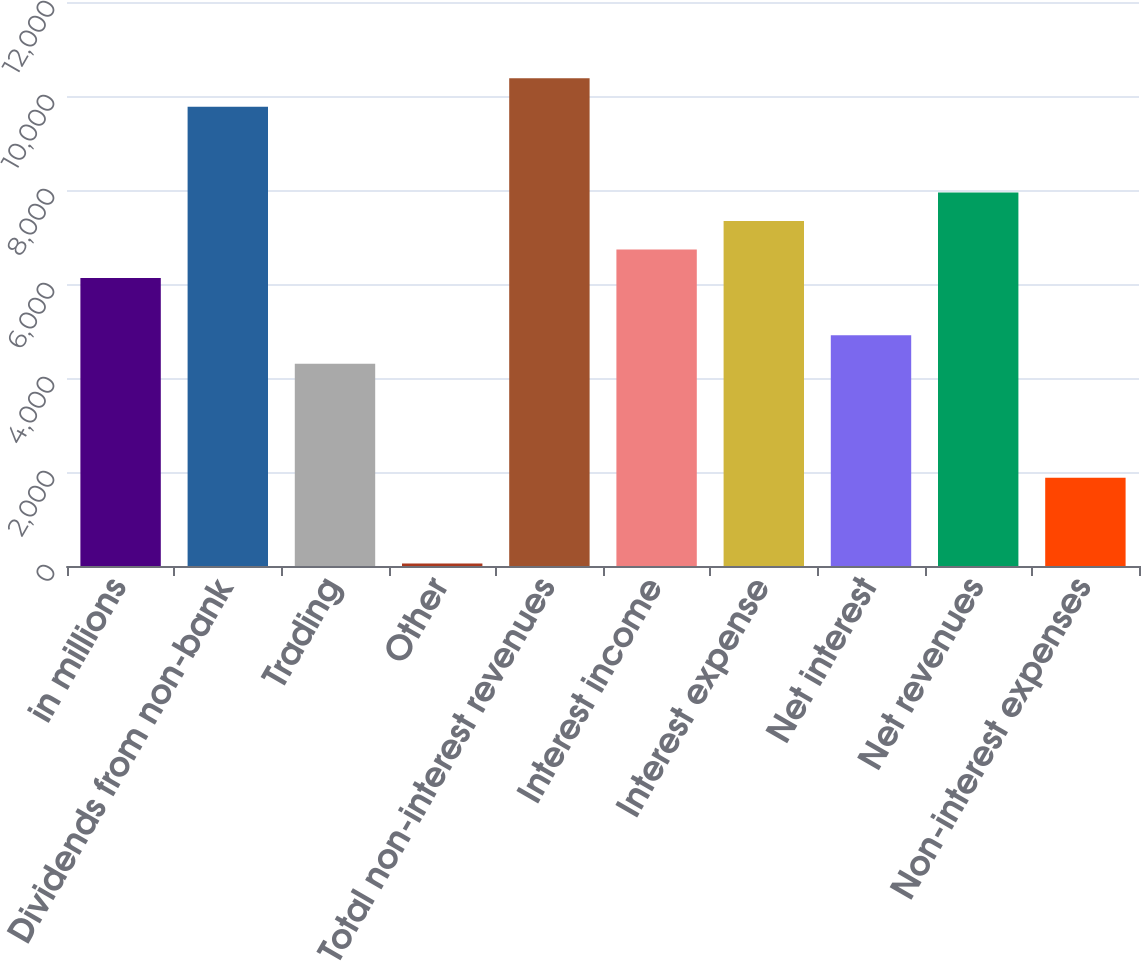Convert chart. <chart><loc_0><loc_0><loc_500><loc_500><bar_chart><fcel>in millions<fcel>Dividends from non-bank<fcel>Trading<fcel>Other<fcel>Total non-interest revenues<fcel>Interest income<fcel>Interest expense<fcel>Net interest<fcel>Net revenues<fcel>Non-interest expenses<nl><fcel>6127<fcel>9771.4<fcel>4304.8<fcel>53<fcel>10378.8<fcel>6734.4<fcel>7341.8<fcel>4912.2<fcel>7949.2<fcel>1875.2<nl></chart> 